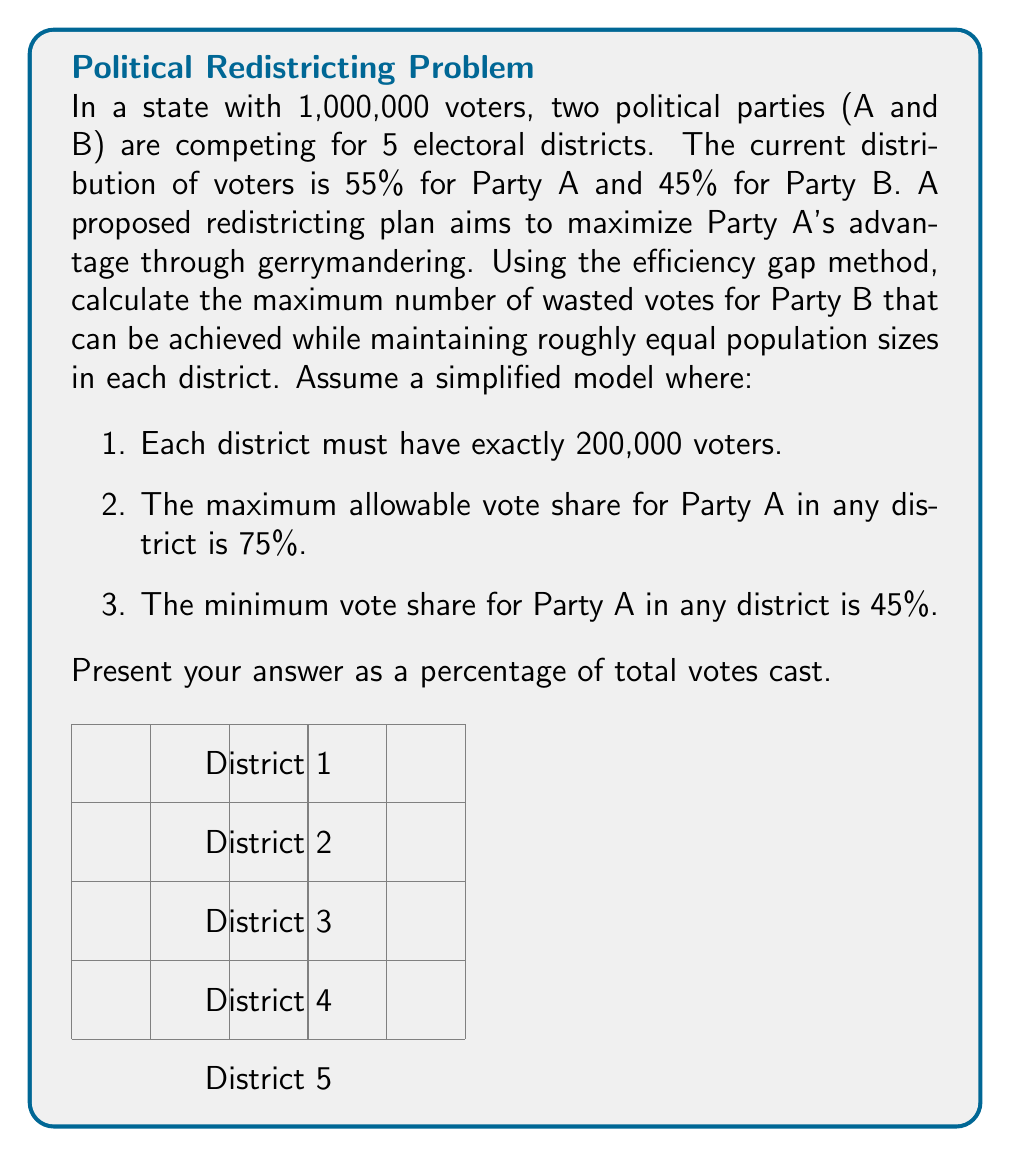Show me your answer to this math problem. Let's approach this step-by-step:

1) First, we need to understand the efficiency gap method. Wasted votes are:
   - All votes cast for the losing party in a district
   - All votes cast for the winning party in excess of what was needed to win (50% + 1 vote)

2) To maximize Party B's wasted votes, we should:
   - Pack as many Party B voters as possible into a few districts (up to 55% for Party B, or 45% for Party A)
   - Crack the remaining Party B voters across districts where Party A wins with 75% of the vote

3) Let's distribute the districts:
   - 2 districts with 45% Party A (55% Party B)
   - 3 districts with 75% Party A (25% Party B)

4) Calculate votes in each type of district:
   - 45% A districts: 90,000 A, 110,000 B
   - 75% A districts: 150,000 A, 50,000 B

5) Calculate wasted votes for Party B:
   - In 45% A districts: 9,999 wasted (110,000 - 100,001)
   - In 75% A districts: All 50,000 wasted

6) Total wasted votes for Party B:
   $$(2 \times 9,999) + (3 \times 50,000) = 169,998$$

7) Calculate the percentage:
   $$\frac{169,998}{1,000,000} \times 100 \approx 17.00\%$$
Answer: 17.00% 